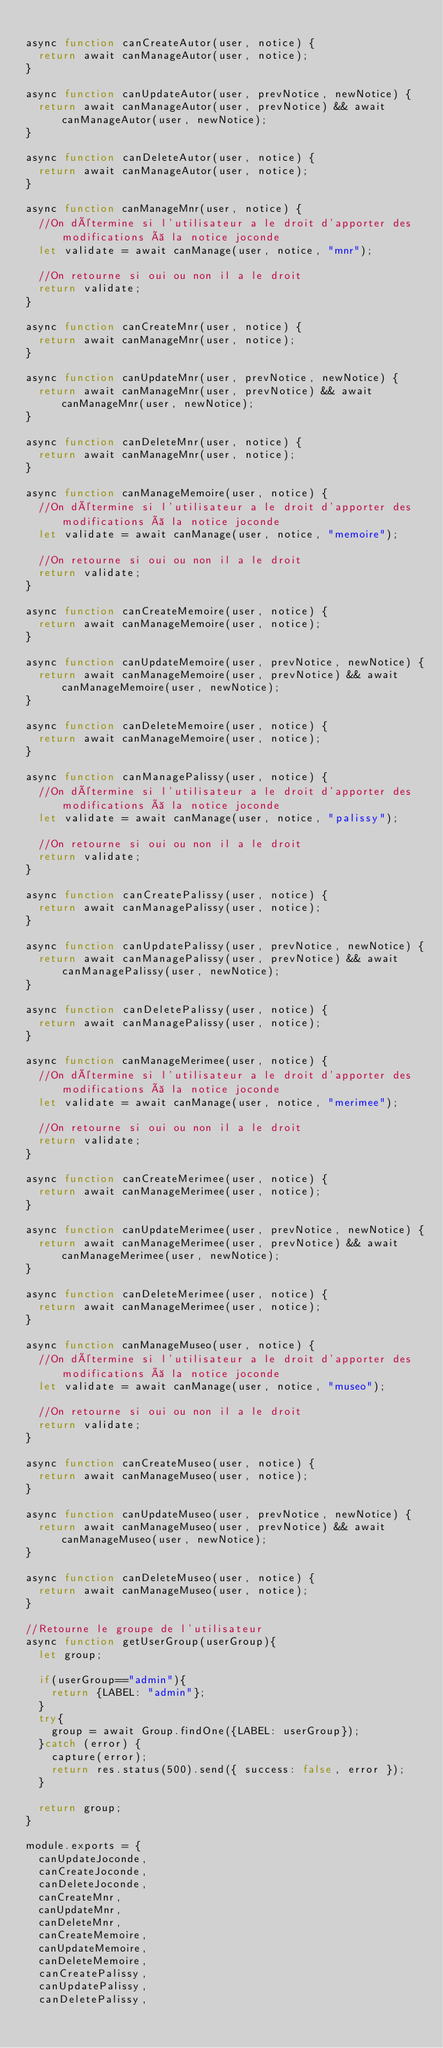Convert code to text. <code><loc_0><loc_0><loc_500><loc_500><_JavaScript_>
async function canCreateAutor(user, notice) {
  return await canManageAutor(user, notice);
}

async function canUpdateAutor(user, prevNotice, newNotice) {
  return await canManageAutor(user, prevNotice) && await canManageAutor(user, newNotice);
}

async function canDeleteAutor(user, notice) {
  return await canManageAutor(user, notice);
}

async function canManageMnr(user, notice) {
  //On détermine si l'utilisateur a le droit d'apporter des modifications à la notice joconde
  let validate = await canManage(user, notice, "mnr");

  //On retourne si oui ou non il a le droit
  return validate;
}

async function canCreateMnr(user, notice) {
  return await canManageMnr(user, notice);
}

async function canUpdateMnr(user, prevNotice, newNotice) {
  return await canManageMnr(user, prevNotice) && await canManageMnr(user, newNotice);
}

async function canDeleteMnr(user, notice) {
  return await canManageMnr(user, notice);
}

async function canManageMemoire(user, notice) {
  //On détermine si l'utilisateur a le droit d'apporter des modifications à la notice joconde
  let validate = await canManage(user, notice, "memoire");

  //On retourne si oui ou non il a le droit
  return validate;
}

async function canCreateMemoire(user, notice) {
  return await canManageMemoire(user, notice);
}

async function canUpdateMemoire(user, prevNotice, newNotice) {
  return await canManageMemoire(user, prevNotice) && await canManageMemoire(user, newNotice);
}

async function canDeleteMemoire(user, notice) {
  return await canManageMemoire(user, notice);
}

async function canManagePalissy(user, notice) {
  //On détermine si l'utilisateur a le droit d'apporter des modifications à la notice joconde
  let validate = await canManage(user, notice, "palissy");

  //On retourne si oui ou non il a le droit
  return validate;
}

async function canCreatePalissy(user, notice) {
  return await canManagePalissy(user, notice);
}

async function canUpdatePalissy(user, prevNotice, newNotice) {
  return await canManagePalissy(user, prevNotice) && await canManagePalissy(user, newNotice);
}

async function canDeletePalissy(user, notice) {
  return await canManagePalissy(user, notice);
}

async function canManageMerimee(user, notice) {
  //On détermine si l'utilisateur a le droit d'apporter des modifications à la notice joconde
  let validate = await canManage(user, notice, "merimee");

  //On retourne si oui ou non il a le droit
  return validate;
}

async function canCreateMerimee(user, notice) {
  return await canManageMerimee(user, notice);
}

async function canUpdateMerimee(user, prevNotice, newNotice) {
  return await canManageMerimee(user, prevNotice) && await canManageMerimee(user, newNotice);
}

async function canDeleteMerimee(user, notice) {
  return await canManageMerimee(user, notice);
}

async function canManageMuseo(user, notice) {
  //On détermine si l'utilisateur a le droit d'apporter des modifications à la notice joconde
  let validate = await canManage(user, notice, "museo");

  //On retourne si oui ou non il a le droit
  return validate;
}

async function canCreateMuseo(user, notice) {
  return await canManageMuseo(user, notice);
}

async function canUpdateMuseo(user, prevNotice, newNotice) {
  return await canManageMuseo(user, prevNotice) && await canManageMuseo(user, newNotice);
}

async function canDeleteMuseo(user, notice) {
  return await canManageMuseo(user, notice);
}

//Retourne le groupe de l'utilisateur
async function getUserGroup(userGroup){
  let group;

  if(userGroup=="admin"){
    return {LABEL: "admin"};
  }
  try{
    group = await Group.findOne({LABEL: userGroup});
  }catch (error) {
    capture(error);
    return res.status(500).send({ success: false, error });
  }

  return group;
}

module.exports = {
  canUpdateJoconde,
  canCreateJoconde,
  canDeleteJoconde,
  canCreateMnr,
  canUpdateMnr,
  canDeleteMnr,
  canCreateMemoire,
  canUpdateMemoire,
  canDeleteMemoire,
  canCreatePalissy,
  canUpdatePalissy,
  canDeletePalissy,</code> 